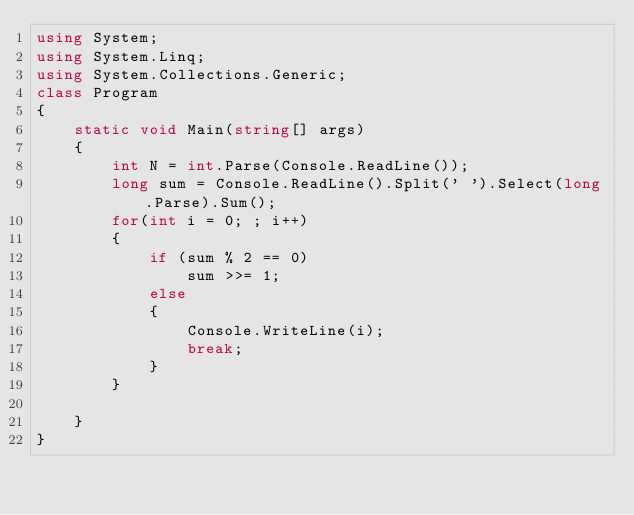<code> <loc_0><loc_0><loc_500><loc_500><_C#_>using System;
using System.Linq;
using System.Collections.Generic;
class Program
{
    static void Main(string[] args)
    {
        int N = int.Parse(Console.ReadLine());
        long sum = Console.ReadLine().Split(' ').Select(long.Parse).Sum();
        for(int i = 0; ; i++)
        {
            if (sum % 2 == 0)
                sum >>= 1;
            else
            {
                Console.WriteLine(i);
                break;
            }
        }

    }
}
</code> 